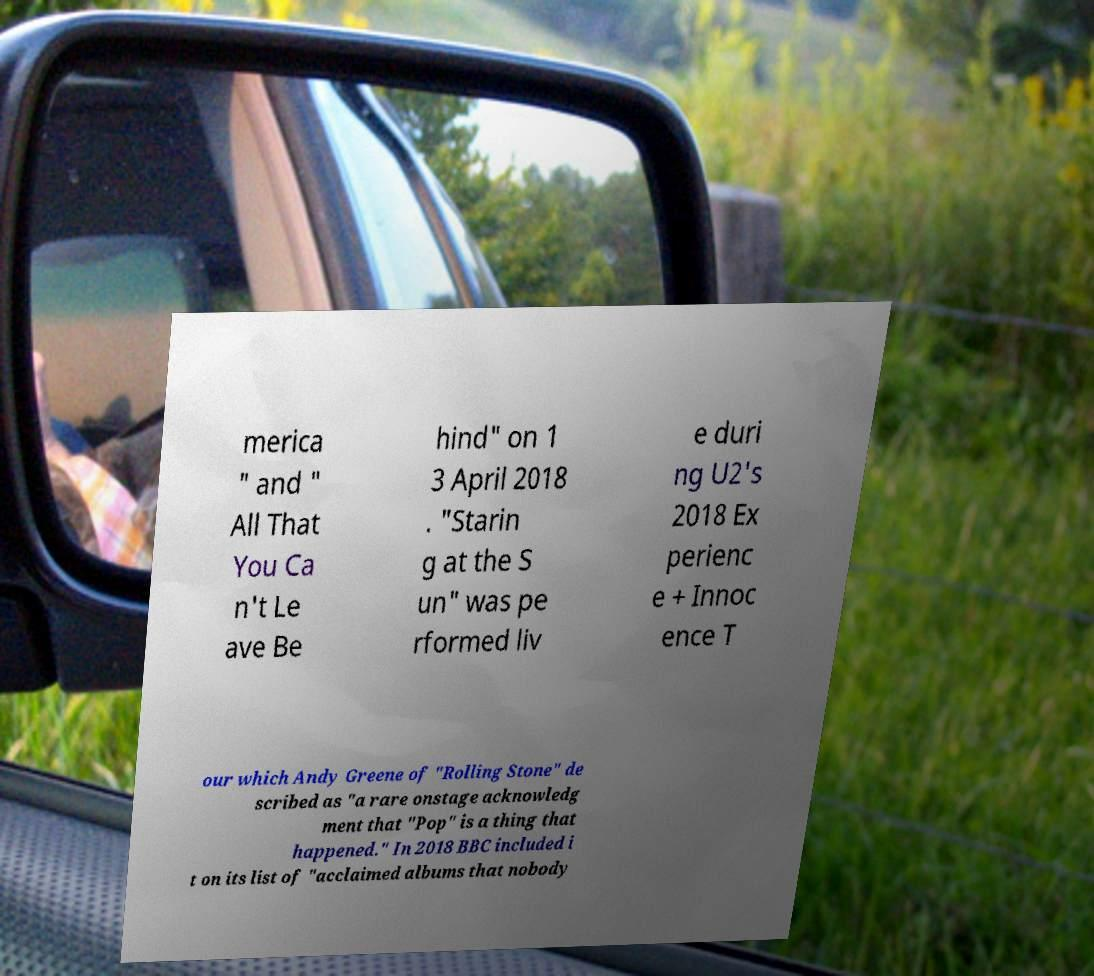Could you extract and type out the text from this image? merica " and " All That You Ca n't Le ave Be hind" on 1 3 April 2018 . "Starin g at the S un" was pe rformed liv e duri ng U2's 2018 Ex perienc e + Innoc ence T our which Andy Greene of "Rolling Stone" de scribed as "a rare onstage acknowledg ment that "Pop" is a thing that happened." In 2018 BBC included i t on its list of "acclaimed albums that nobody 